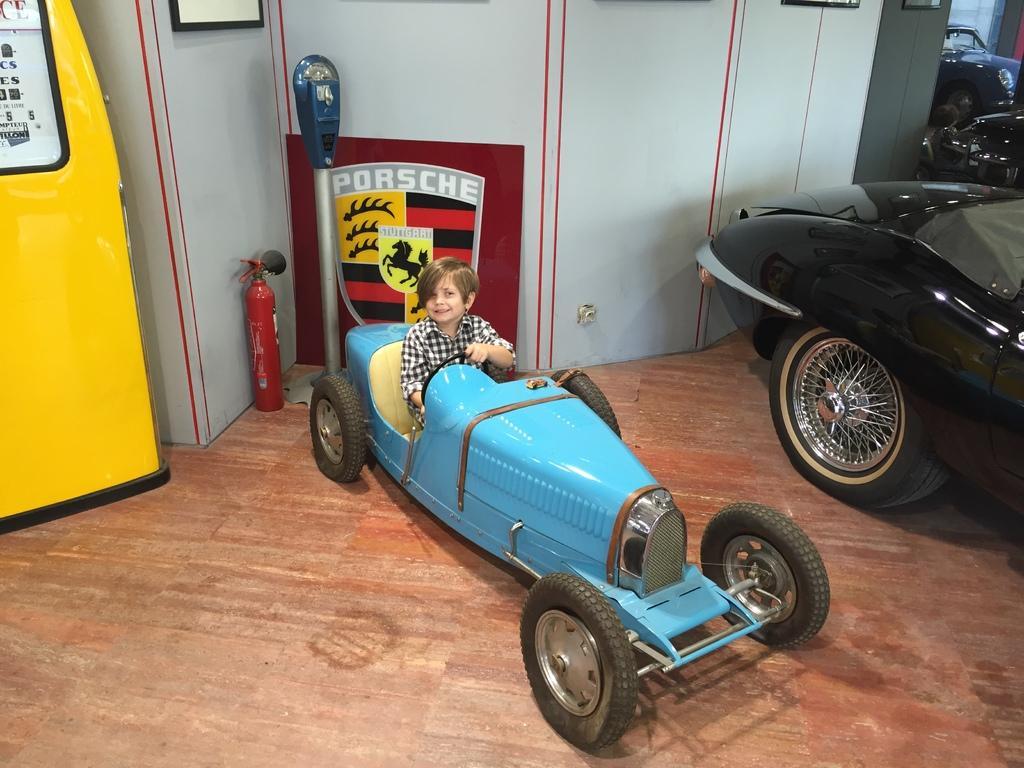Describe this image in one or two sentences. In this picture I can see a little boy is sitting on a blue color car, on the right side there is another car in black color. On the left side there is an iron box in yellow color, beside it there is a fire extinguisher. 